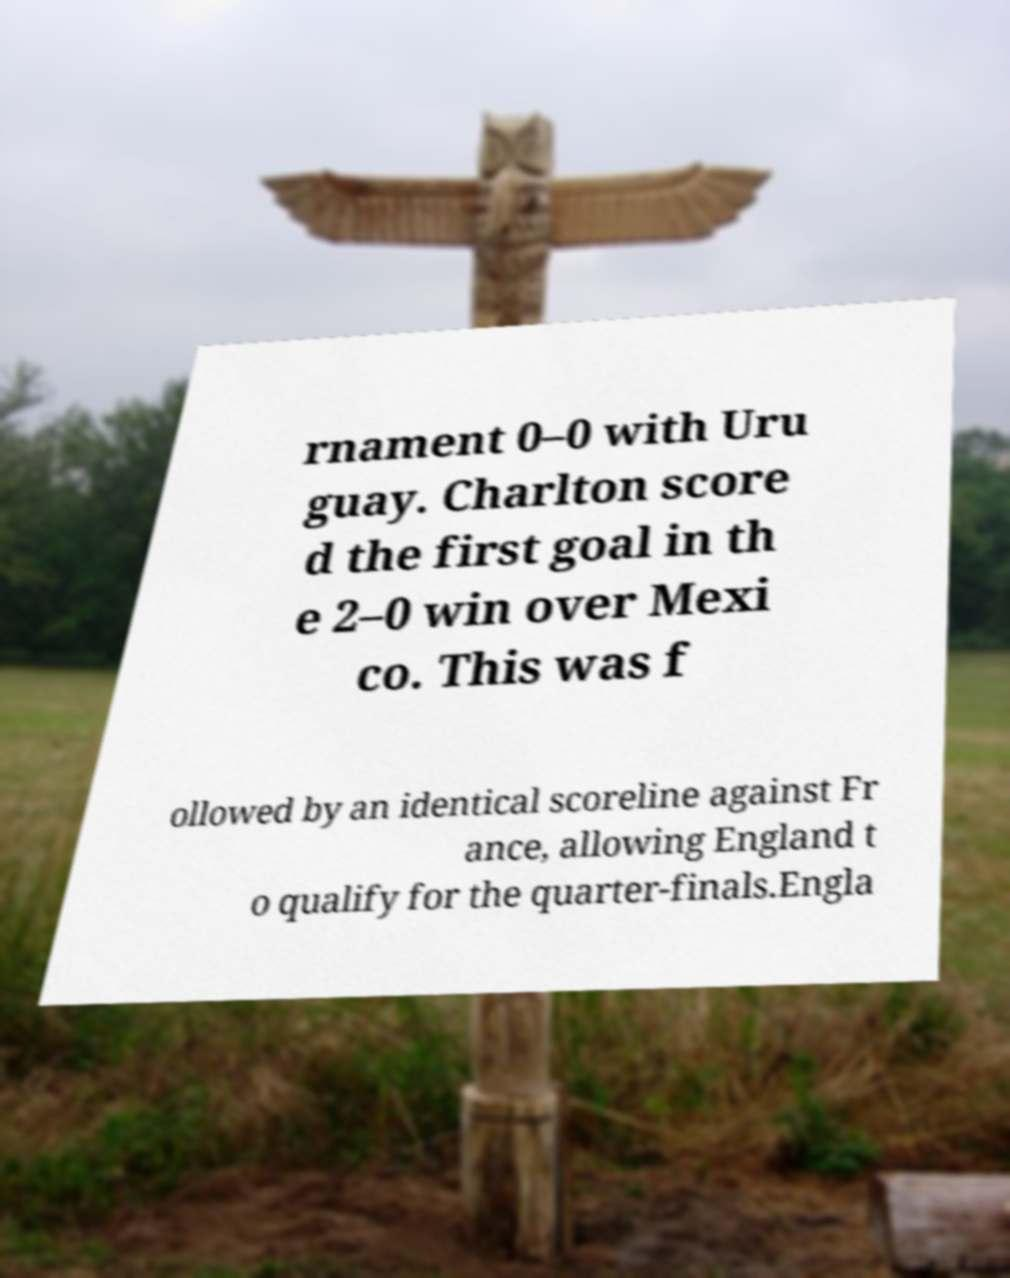Please read and relay the text visible in this image. What does it say? rnament 0–0 with Uru guay. Charlton score d the first goal in th e 2–0 win over Mexi co. This was f ollowed by an identical scoreline against Fr ance, allowing England t o qualify for the quarter-finals.Engla 